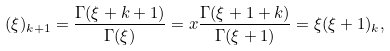Convert formula to latex. <formula><loc_0><loc_0><loc_500><loc_500>( \xi ) _ { k + 1 } = \frac { \Gamma ( \xi + k + 1 ) } { \Gamma ( \xi ) } = x \frac { \Gamma ( \xi + 1 + k ) } { \Gamma ( \xi + 1 ) } = \xi ( \xi + 1 ) _ { k } ,</formula> 